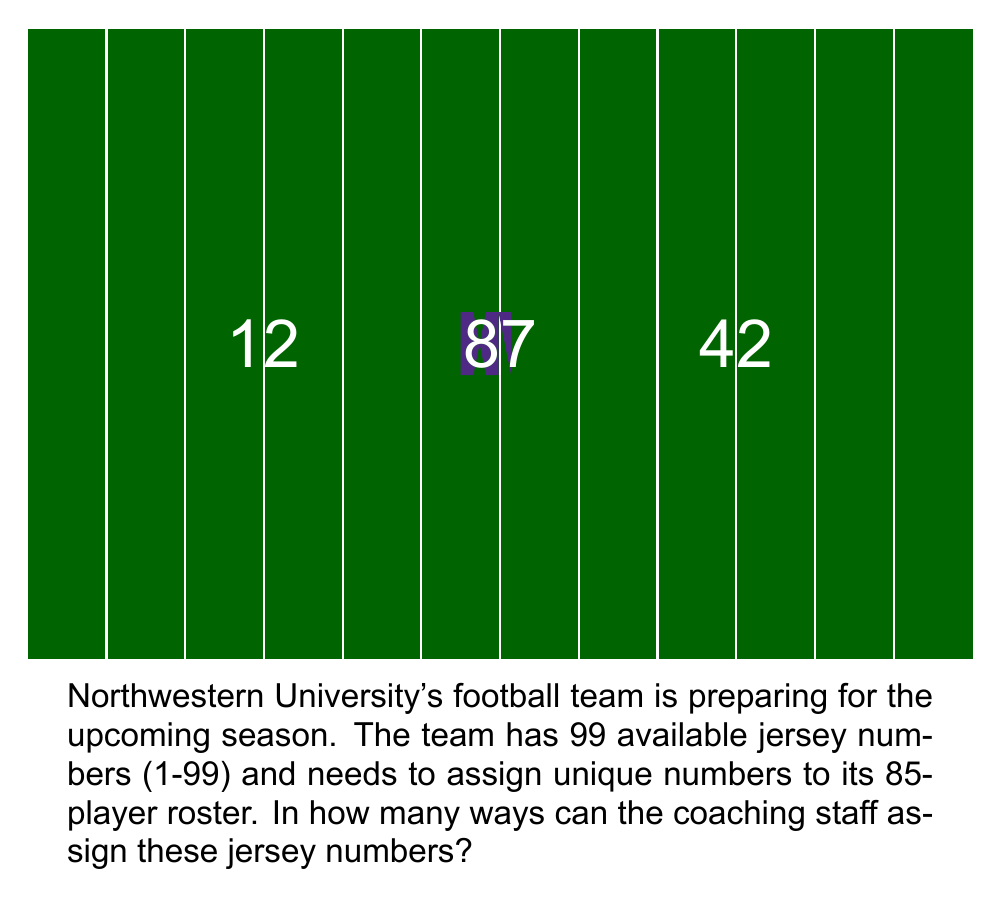Help me with this question. Let's approach this step-by-step:

1) This is a combination problem. We need to select 85 numbers out of 99 available numbers, where the order doesn't matter (since we're just concerned with which numbers are used, not which player gets which number).

2) The formula for combinations is:

   $$C(n,r) = \frac{n!}{r!(n-r)!}$$

   where $n$ is the total number of items to choose from, and $r$ is the number of items being chosen.

3) In this case, $n = 99$ (available numbers) and $r = 85$ (roster size).

4) Plugging these values into our formula:

   $$C(99,85) = \frac{99!}{85!(99-85)!} = \frac{99!}{85!14!}$$

5) This can be calculated as:

   $$\frac{99 \cdot 98 \cdot 97 \cdot 96 \cdot 95 \cdot 94 \cdot 93 \cdot 92 \cdot 91 \cdot 90 \cdot 89 \cdot 88 \cdot 87 \cdot 86}{14 \cdot 13 \cdot 12 \cdot 11 \cdot 10 \cdot 9 \cdot 8 \cdot 7 \cdot 6 \cdot 5 \cdot 4 \cdot 3 \cdot 2 \cdot 1}$$

6) This evaluates to 31,724,417,661,228,300.

Therefore, there are 31,724,417,661,228,300 unique ways to assign jersey numbers to Northwestern's 85-player roster.
Answer: 31,724,417,661,228,300 